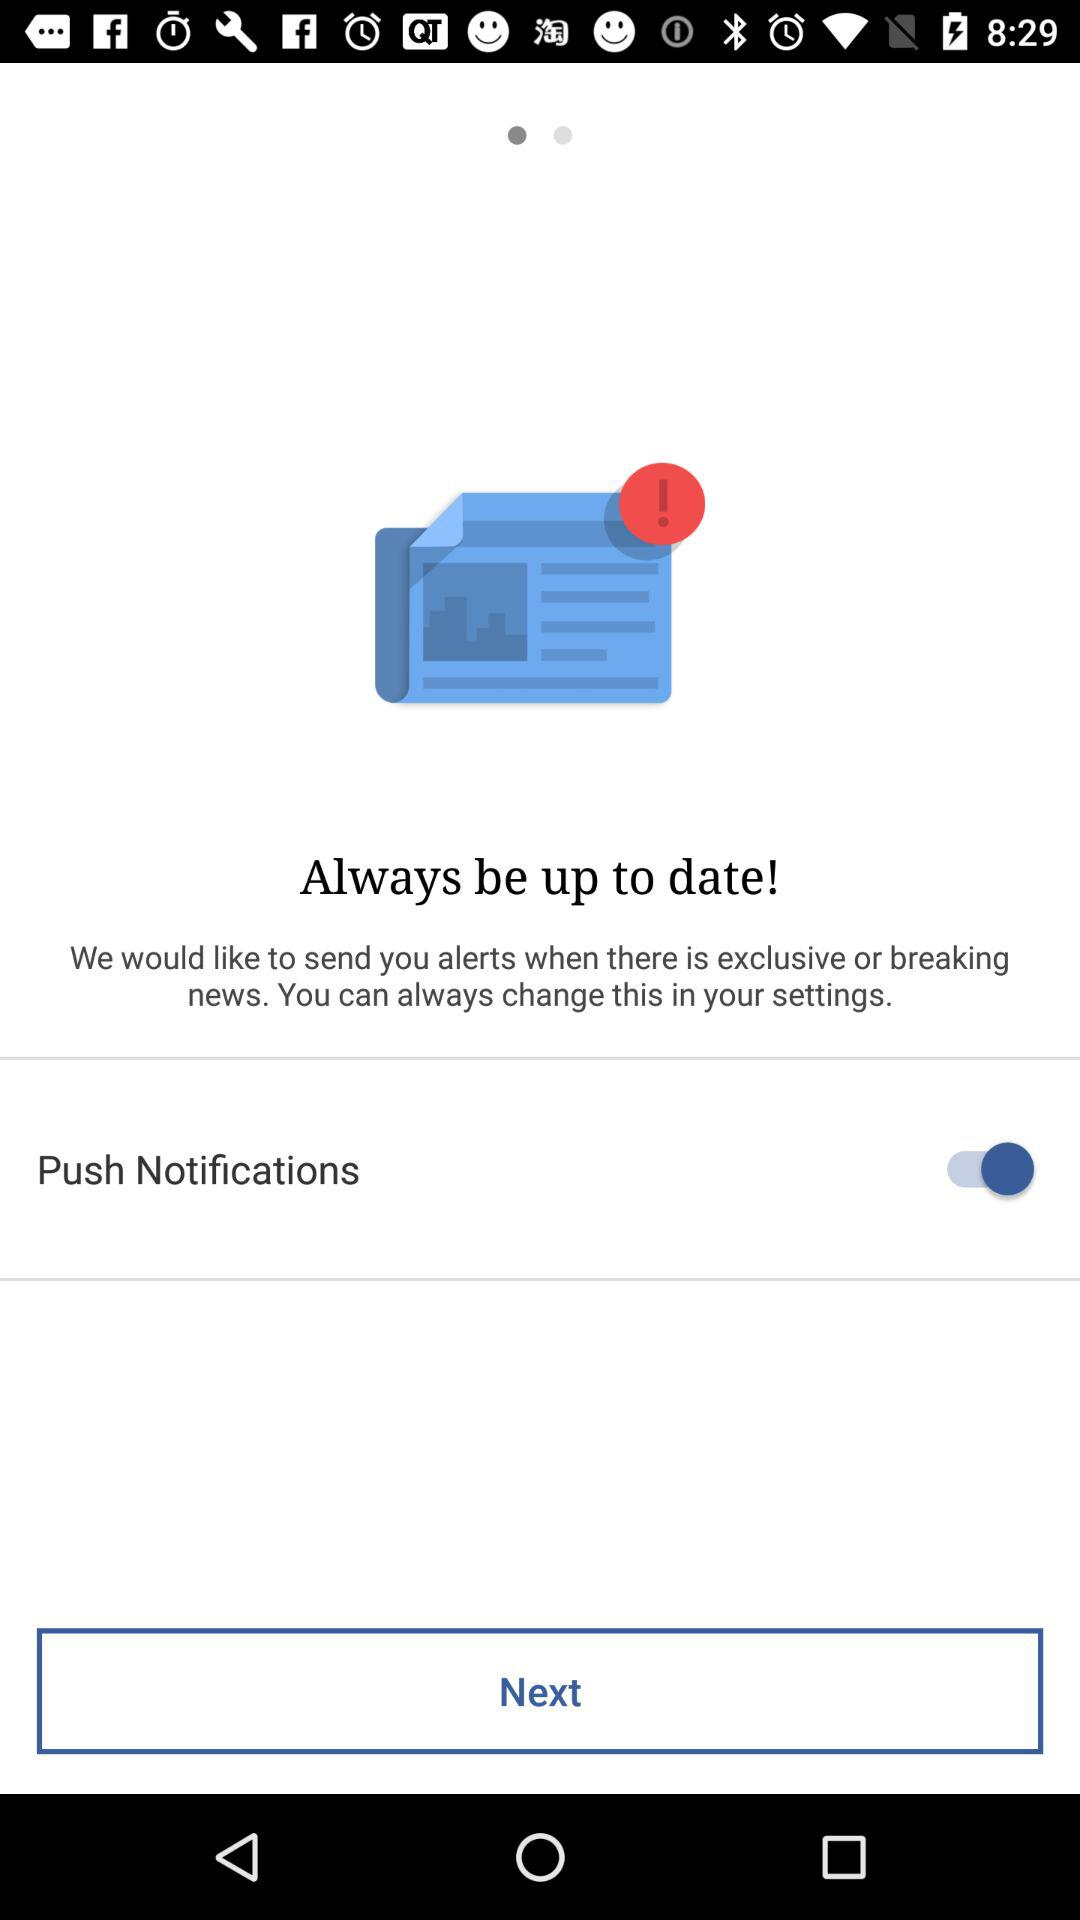What is the status of "Push Notifications"? The status is "on". 